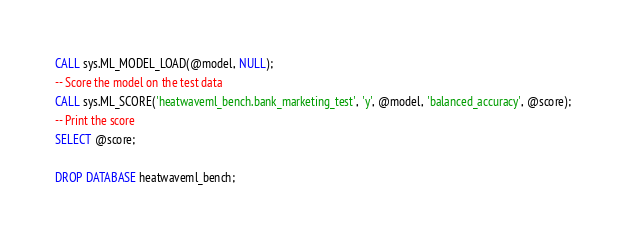<code> <loc_0><loc_0><loc_500><loc_500><_SQL_>CALL sys.ML_MODEL_LOAD(@model, NULL);
-- Score the model on the test data
CALL sys.ML_SCORE('heatwaveml_bench.bank_marketing_test', 'y', @model, 'balanced_accuracy', @score);
-- Print the score
SELECT @score;

DROP DATABASE heatwaveml_bench;</code> 